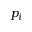<formula> <loc_0><loc_0><loc_500><loc_500>p _ { i }</formula> 